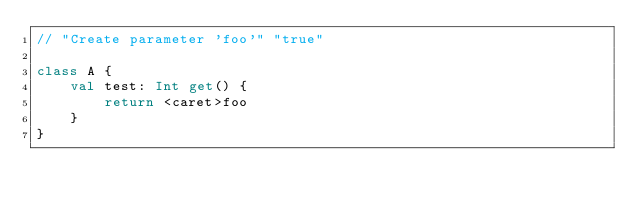Convert code to text. <code><loc_0><loc_0><loc_500><loc_500><_Kotlin_>// "Create parameter 'foo'" "true"

class A {
    val test: Int get() {
        return <caret>foo
    }
}</code> 